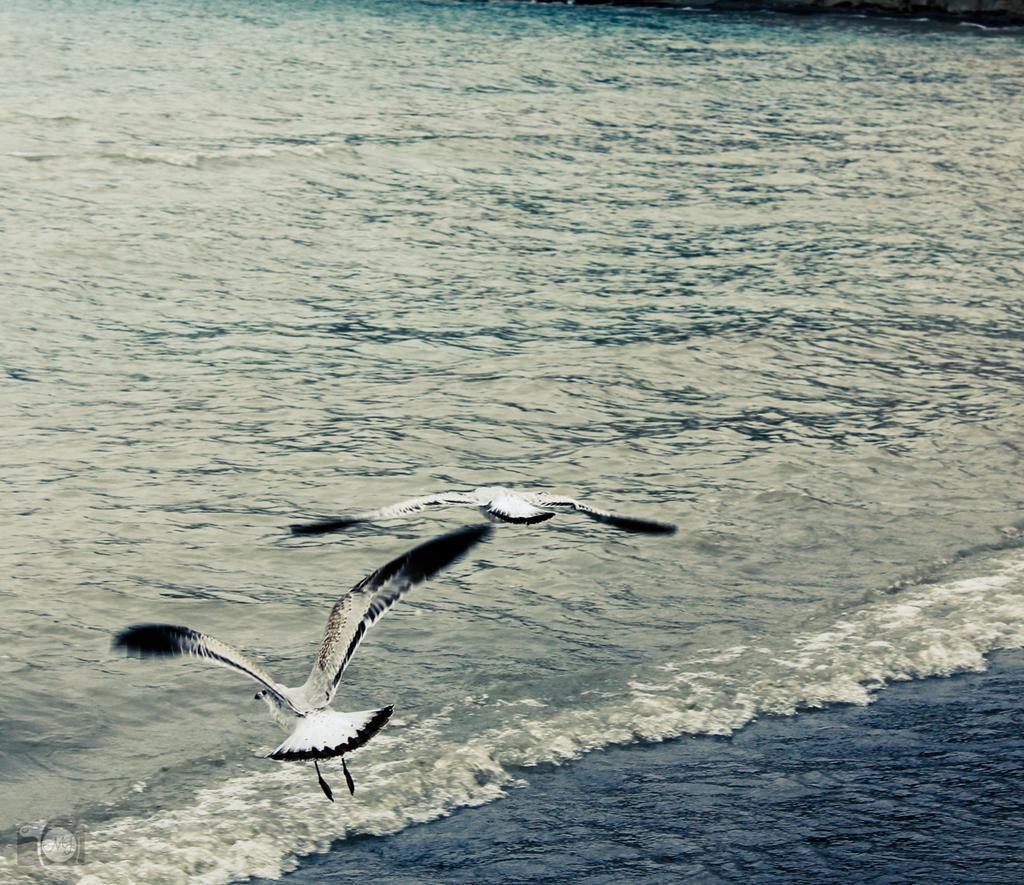What type of landscape is depicted in the image? There is a sea in the image. What animals can be seen in the image? There are two birds flying in the air. What type of jewel is being carried by the birds in the image? There are no jewels present in the image; it only features two birds flying in the air and a sea. 